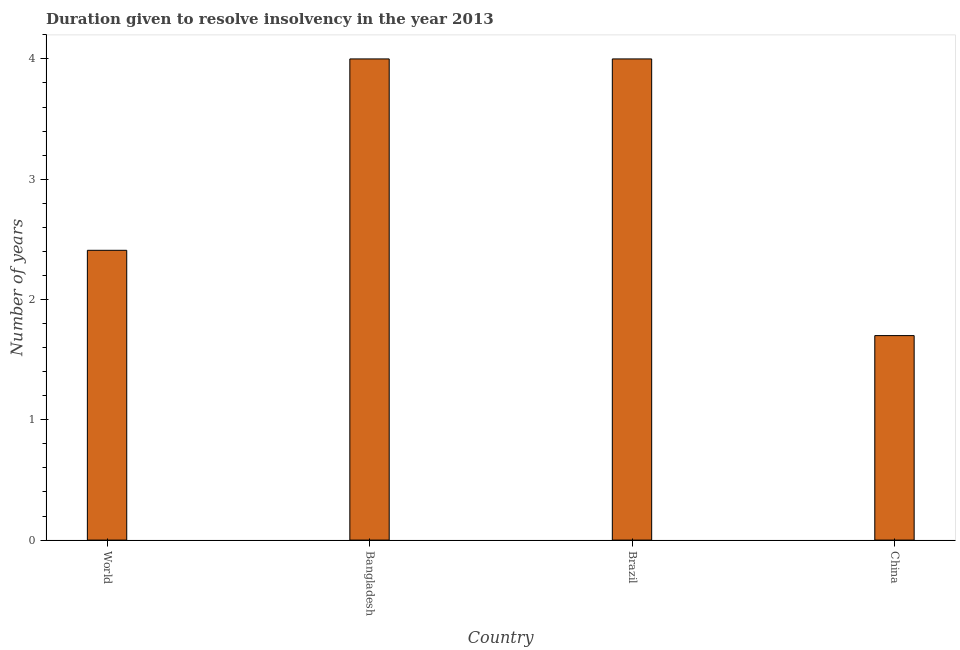Does the graph contain grids?
Make the answer very short. No. What is the title of the graph?
Offer a very short reply. Duration given to resolve insolvency in the year 2013. What is the label or title of the Y-axis?
Offer a terse response. Number of years. What is the number of years to resolve insolvency in World?
Offer a very short reply. 2.41. Across all countries, what is the minimum number of years to resolve insolvency?
Your answer should be very brief. 1.7. In which country was the number of years to resolve insolvency maximum?
Your response must be concise. Bangladesh. In which country was the number of years to resolve insolvency minimum?
Your response must be concise. China. What is the sum of the number of years to resolve insolvency?
Ensure brevity in your answer.  12.11. What is the average number of years to resolve insolvency per country?
Your answer should be very brief. 3.03. What is the median number of years to resolve insolvency?
Your response must be concise. 3.2. What is the ratio of the number of years to resolve insolvency in Brazil to that in China?
Your answer should be compact. 2.35. Is the sum of the number of years to resolve insolvency in Bangladesh and China greater than the maximum number of years to resolve insolvency across all countries?
Your answer should be very brief. Yes. What is the difference between the highest and the lowest number of years to resolve insolvency?
Offer a very short reply. 2.3. What is the difference between two consecutive major ticks on the Y-axis?
Make the answer very short. 1. Are the values on the major ticks of Y-axis written in scientific E-notation?
Your answer should be very brief. No. What is the Number of years in World?
Your answer should be compact. 2.41. What is the Number of years in Bangladesh?
Keep it short and to the point. 4. What is the Number of years of China?
Your response must be concise. 1.7. What is the difference between the Number of years in World and Bangladesh?
Provide a short and direct response. -1.59. What is the difference between the Number of years in World and Brazil?
Give a very brief answer. -1.59. What is the difference between the Number of years in World and China?
Give a very brief answer. 0.71. What is the difference between the Number of years in Bangladesh and China?
Keep it short and to the point. 2.3. What is the ratio of the Number of years in World to that in Bangladesh?
Give a very brief answer. 0.6. What is the ratio of the Number of years in World to that in Brazil?
Your response must be concise. 0.6. What is the ratio of the Number of years in World to that in China?
Ensure brevity in your answer.  1.42. What is the ratio of the Number of years in Bangladesh to that in Brazil?
Offer a very short reply. 1. What is the ratio of the Number of years in Bangladesh to that in China?
Your answer should be very brief. 2.35. What is the ratio of the Number of years in Brazil to that in China?
Provide a succinct answer. 2.35. 